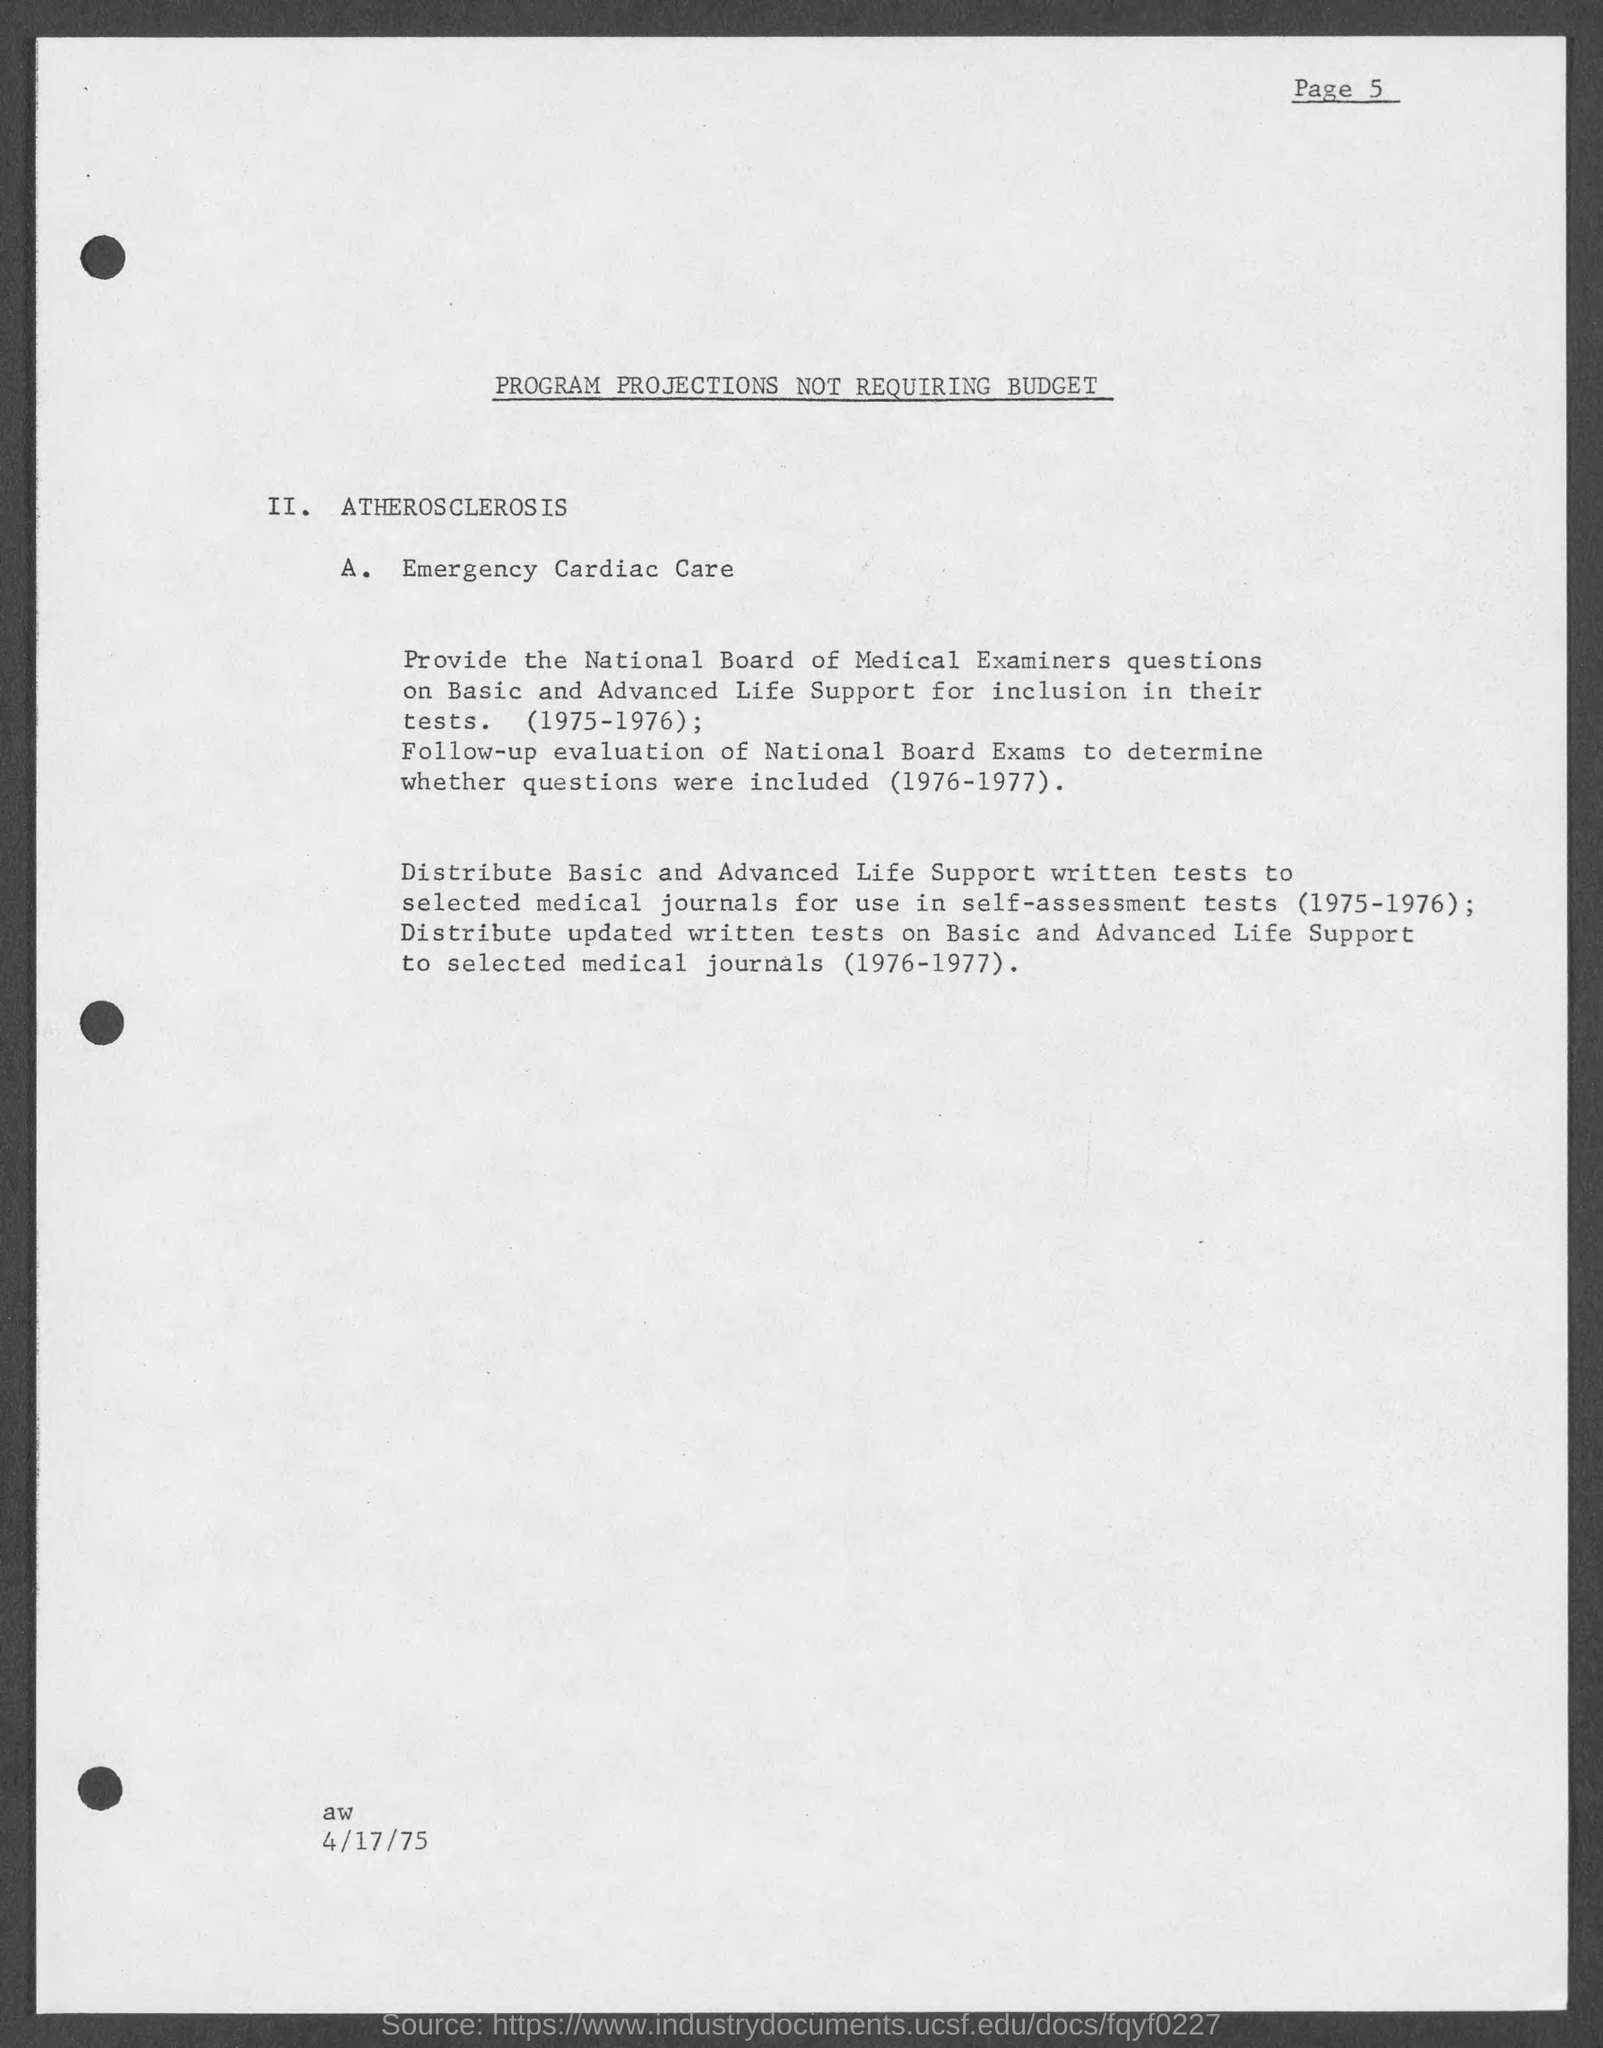What is the page number on this document?
Keep it short and to the point. Page 5. What is the document title?
Your response must be concise. PROGRAM PROJECTIONS NOT REQUIRING BUDGET. What is point A.?
Your answer should be very brief. Emergency Cardiac Care. When is the document dated?
Ensure brevity in your answer.  4/17/75. 